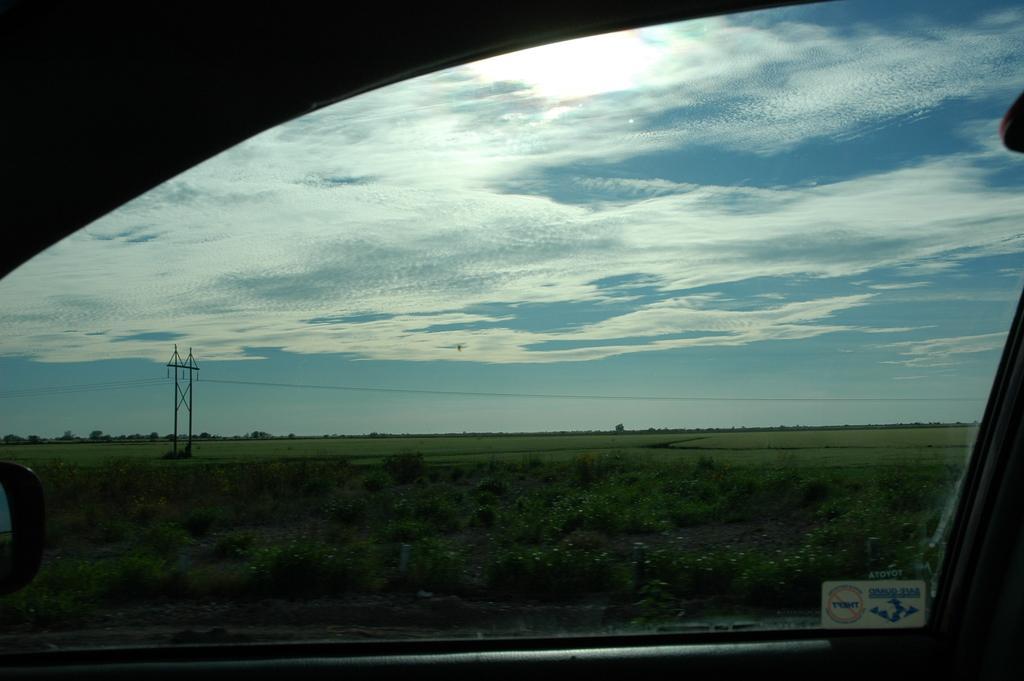Please provide a concise description of this image. In this image there is a vehicle on the road, few trees, plants, agricultural field, few poles and electric cables, some clouds in the sky. 